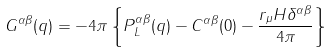<formula> <loc_0><loc_0><loc_500><loc_500>G ^ { \alpha \beta } ( q ) = - 4 \pi \left \{ P _ { L } ^ { \alpha \beta } ( q ) - C ^ { \alpha \beta } ( 0 ) - \frac { r _ { \mu } H \delta ^ { \alpha \beta } } { 4 \pi } \right \}</formula> 